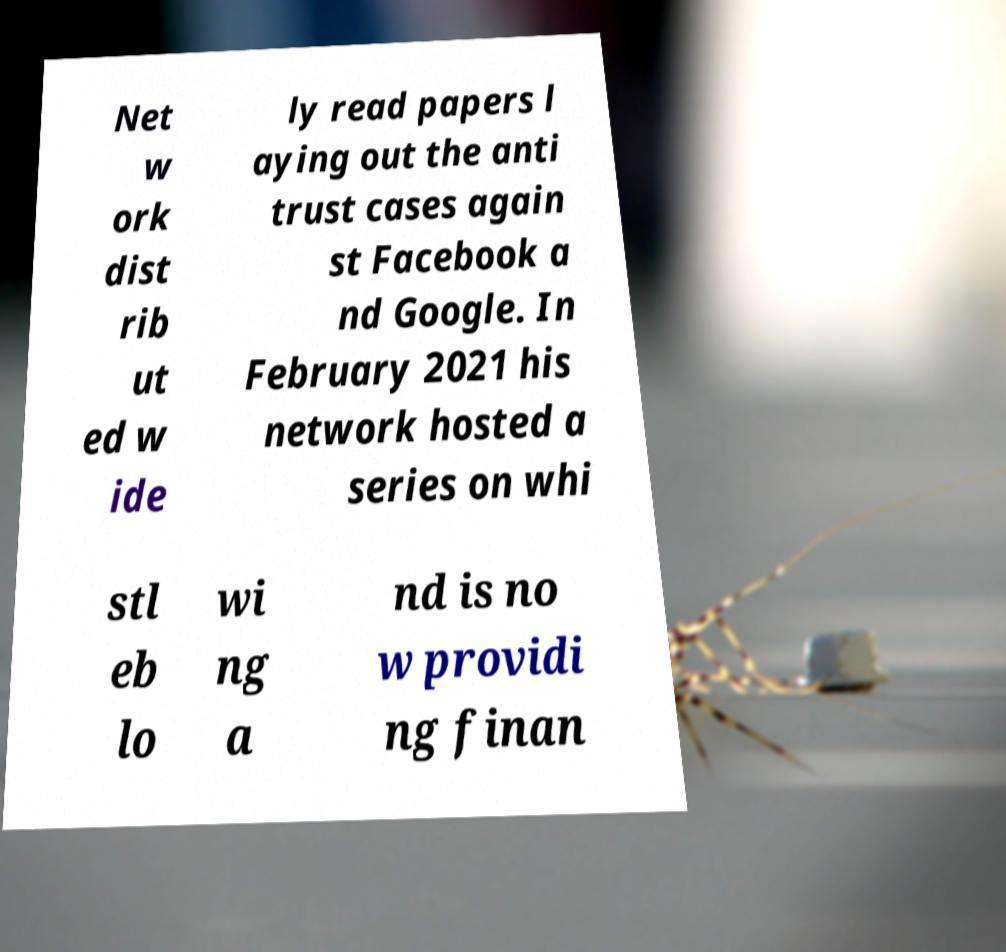Could you extract and type out the text from this image? Net w ork dist rib ut ed w ide ly read papers l aying out the anti trust cases again st Facebook a nd Google. In February 2021 his network hosted a series on whi stl eb lo wi ng a nd is no w providi ng finan 